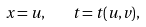Convert formula to latex. <formula><loc_0><loc_0><loc_500><loc_500>x = u , \text { } \text { } \text { } \text { } t = t ( u , v ) ,</formula> 